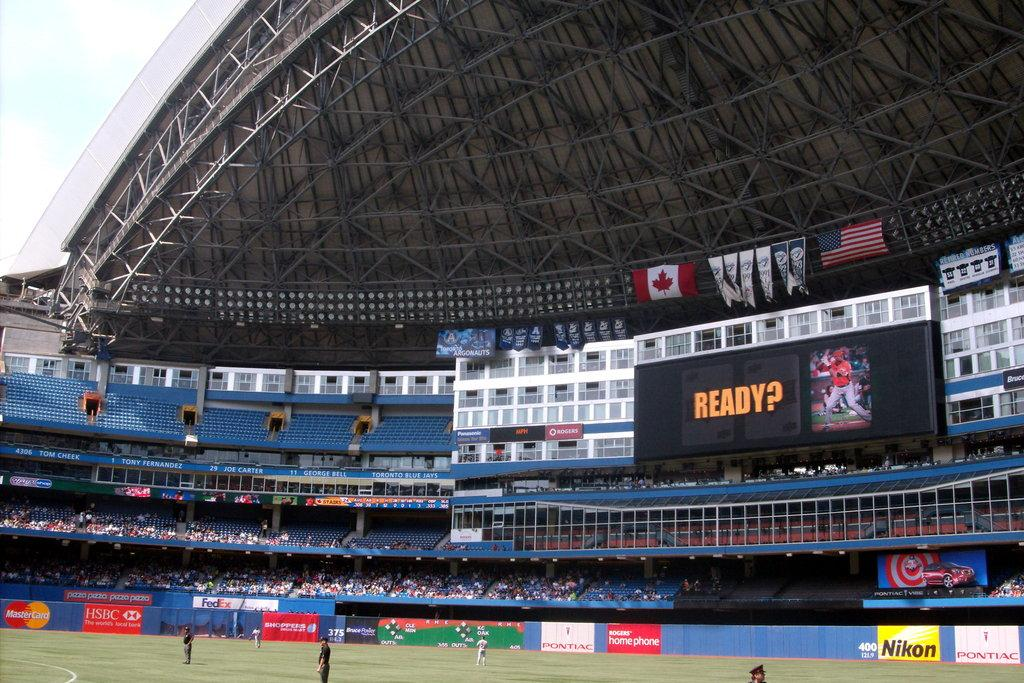Provide a one-sentence caption for the provided image. Sports stadium with the word "ready?" on the scoreboard. 